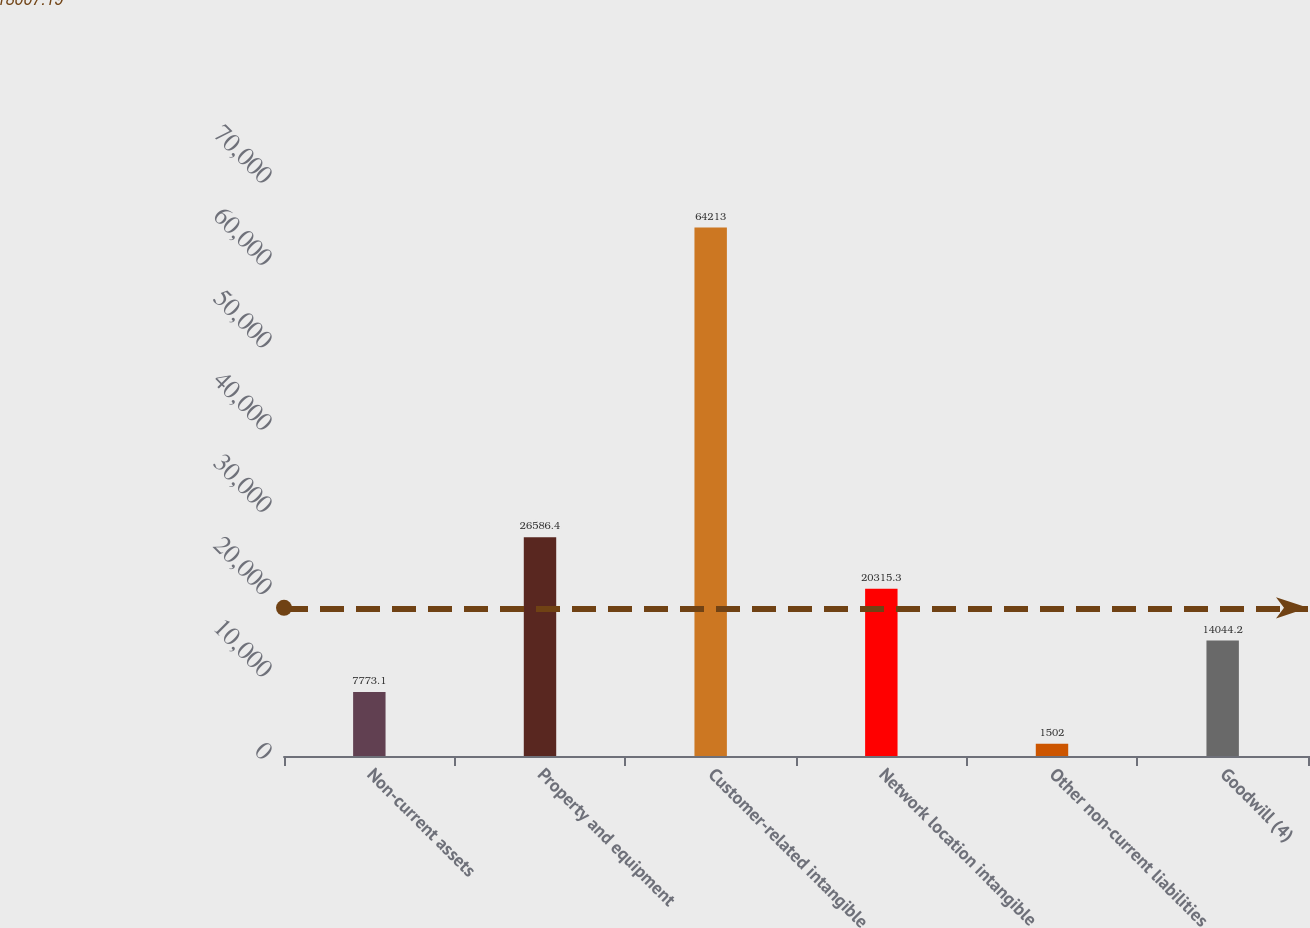Convert chart. <chart><loc_0><loc_0><loc_500><loc_500><bar_chart><fcel>Non-current assets<fcel>Property and equipment<fcel>Customer-related intangible<fcel>Network location intangible<fcel>Other non-current liabilities<fcel>Goodwill (4)<nl><fcel>7773.1<fcel>26586.4<fcel>64213<fcel>20315.3<fcel>1502<fcel>14044.2<nl></chart> 